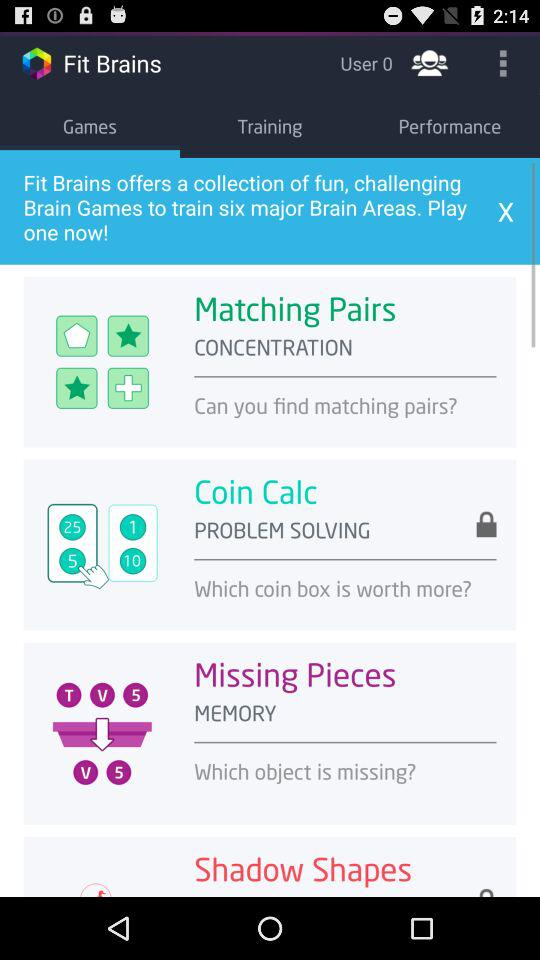How many users are there? There are 0 users. 